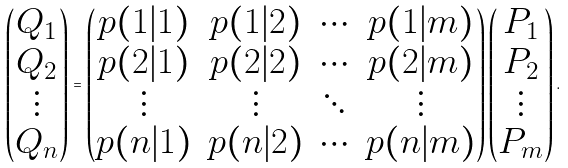Convert formula to latex. <formula><loc_0><loc_0><loc_500><loc_500>\begin{pmatrix} Q _ { 1 } \\ Q _ { 2 } \\ \vdots \\ Q _ { n } \end{pmatrix} = \begin{pmatrix} p ( 1 | 1 ) & p ( 1 | 2 ) & \cdots & p ( 1 | m ) \\ p ( 2 | 1 ) & p ( 2 | 2 ) & \cdots & p ( 2 | m ) \\ \vdots & \vdots & \ddots & \vdots \\ p ( n | 1 ) & p ( n | 2 ) & \cdots & p ( n | m ) \\ \end{pmatrix} \begin{pmatrix} P _ { 1 } \\ P _ { 2 } \\ \vdots \\ P _ { m } \end{pmatrix} .</formula> 